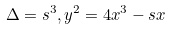<formula> <loc_0><loc_0><loc_500><loc_500>\Delta = s ^ { 3 } , y ^ { 2 } = 4 x ^ { 3 } - s x</formula> 